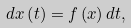<formula> <loc_0><loc_0><loc_500><loc_500>d x \left ( t \right ) = f \left ( x \right ) d t ,</formula> 